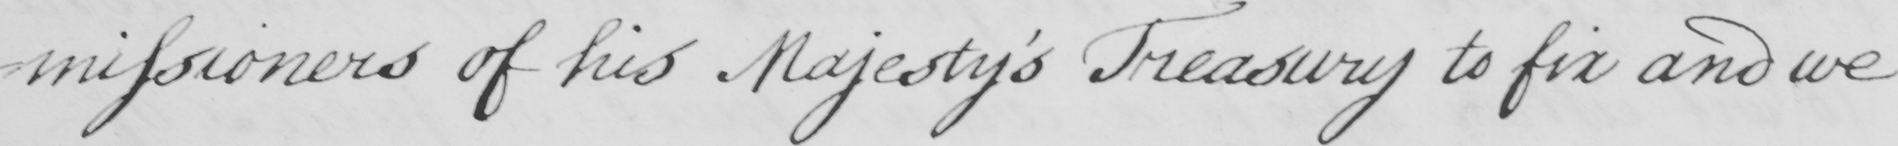What does this handwritten line say? -missioners of his Majesty ' s Treasury to fix and we 